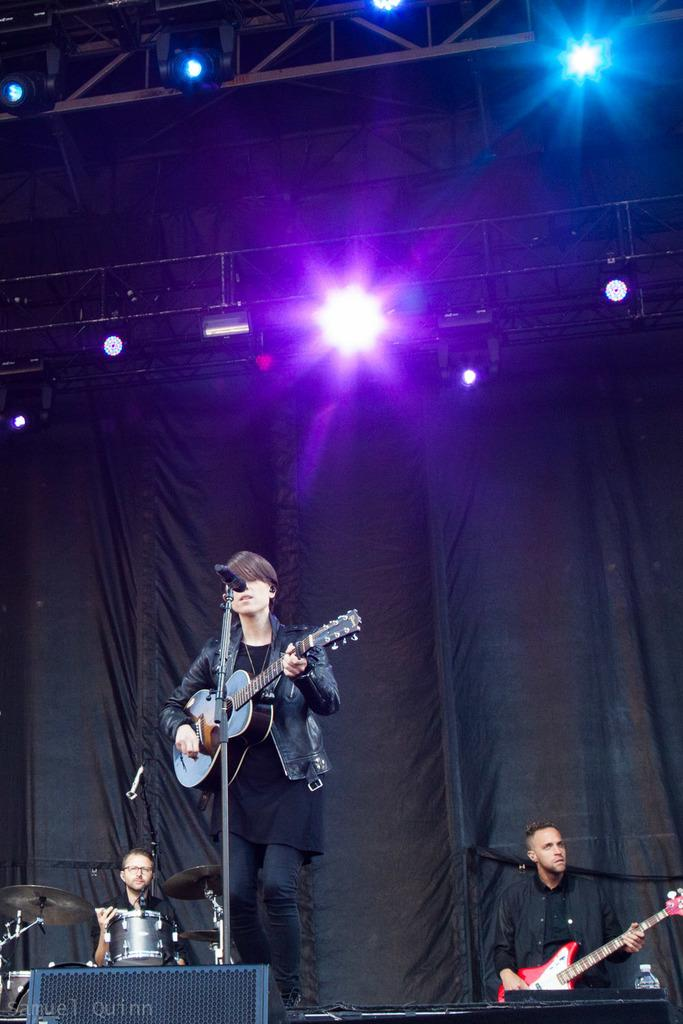What are the persons on the dais doing in the image? The persons on the dais are holding musical instruments. What can be seen in the background of the image? There are electric lights, iron grills, curtains, and a mic in the background. How many visitors are present in the image? There is no mention of visitors in the image; it features persons on a dais holding musical instruments and various elements in the background. 